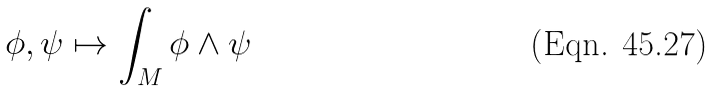<formula> <loc_0><loc_0><loc_500><loc_500>\phi , \psi \mapsto \int _ { M } \phi \wedge \psi</formula> 